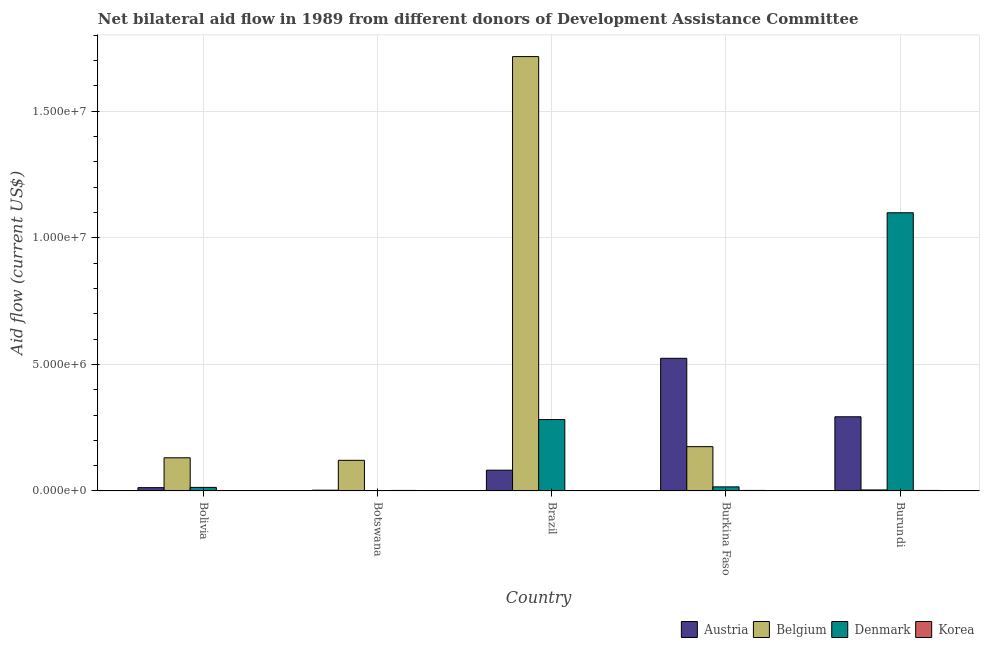How many different coloured bars are there?
Keep it short and to the point. 4. Are the number of bars per tick equal to the number of legend labels?
Your answer should be compact. No. How many bars are there on the 2nd tick from the left?
Your answer should be compact. 3. How many bars are there on the 5th tick from the right?
Make the answer very short. 4. What is the amount of aid given by korea in Burundi?
Offer a very short reply. 2.00e+04. Across all countries, what is the maximum amount of aid given by austria?
Ensure brevity in your answer.  5.24e+06. In which country was the amount of aid given by korea maximum?
Your answer should be compact. Botswana. What is the total amount of aid given by korea in the graph?
Keep it short and to the point. 8.00e+04. What is the difference between the amount of aid given by belgium in Botswana and that in Brazil?
Keep it short and to the point. -1.60e+07. What is the difference between the amount of aid given by austria in Bolivia and the amount of aid given by korea in Botswana?
Make the answer very short. 1.10e+05. What is the average amount of aid given by korea per country?
Your answer should be compact. 1.60e+04. What is the difference between the amount of aid given by denmark and amount of aid given by korea in Burkina Faso?
Offer a terse response. 1.40e+05. What is the ratio of the amount of aid given by korea in Brazil to that in Burkina Faso?
Keep it short and to the point. 0.5. Is the amount of aid given by austria in Brazil less than that in Burkina Faso?
Your answer should be compact. Yes. What is the difference between the highest and the second highest amount of aid given by denmark?
Provide a short and direct response. 8.17e+06. What is the difference between the highest and the lowest amount of aid given by austria?
Give a very brief answer. 5.21e+06. Is it the case that in every country, the sum of the amount of aid given by austria and amount of aid given by korea is greater than the sum of amount of aid given by belgium and amount of aid given by denmark?
Ensure brevity in your answer.  No. Is it the case that in every country, the sum of the amount of aid given by austria and amount of aid given by belgium is greater than the amount of aid given by denmark?
Offer a very short reply. No. How many countries are there in the graph?
Give a very brief answer. 5. Are the values on the major ticks of Y-axis written in scientific E-notation?
Your response must be concise. Yes. Does the graph contain grids?
Provide a short and direct response. Yes. How many legend labels are there?
Offer a terse response. 4. How are the legend labels stacked?
Make the answer very short. Horizontal. What is the title of the graph?
Provide a short and direct response. Net bilateral aid flow in 1989 from different donors of Development Assistance Committee. What is the label or title of the Y-axis?
Your answer should be very brief. Aid flow (current US$). What is the Aid flow (current US$) of Austria in Bolivia?
Your response must be concise. 1.30e+05. What is the Aid flow (current US$) in Belgium in Bolivia?
Your answer should be compact. 1.31e+06. What is the Aid flow (current US$) in Denmark in Bolivia?
Make the answer very short. 1.40e+05. What is the Aid flow (current US$) of Belgium in Botswana?
Provide a short and direct response. 1.21e+06. What is the Aid flow (current US$) in Denmark in Botswana?
Keep it short and to the point. 0. What is the Aid flow (current US$) of Austria in Brazil?
Your answer should be very brief. 8.20e+05. What is the Aid flow (current US$) in Belgium in Brazil?
Keep it short and to the point. 1.72e+07. What is the Aid flow (current US$) in Denmark in Brazil?
Your answer should be very brief. 2.82e+06. What is the Aid flow (current US$) in Austria in Burkina Faso?
Offer a very short reply. 5.24e+06. What is the Aid flow (current US$) of Belgium in Burkina Faso?
Provide a succinct answer. 1.75e+06. What is the Aid flow (current US$) in Korea in Burkina Faso?
Your response must be concise. 2.00e+04. What is the Aid flow (current US$) in Austria in Burundi?
Your answer should be compact. 2.93e+06. What is the Aid flow (current US$) in Denmark in Burundi?
Provide a short and direct response. 1.10e+07. Across all countries, what is the maximum Aid flow (current US$) of Austria?
Your answer should be compact. 5.24e+06. Across all countries, what is the maximum Aid flow (current US$) of Belgium?
Provide a succinct answer. 1.72e+07. Across all countries, what is the maximum Aid flow (current US$) in Denmark?
Provide a succinct answer. 1.10e+07. Across all countries, what is the maximum Aid flow (current US$) of Korea?
Give a very brief answer. 2.00e+04. Across all countries, what is the minimum Aid flow (current US$) of Belgium?
Provide a short and direct response. 4.00e+04. Across all countries, what is the minimum Aid flow (current US$) of Denmark?
Provide a short and direct response. 0. What is the total Aid flow (current US$) in Austria in the graph?
Your response must be concise. 9.15e+06. What is the total Aid flow (current US$) in Belgium in the graph?
Keep it short and to the point. 2.15e+07. What is the total Aid flow (current US$) of Denmark in the graph?
Ensure brevity in your answer.  1.41e+07. What is the total Aid flow (current US$) in Korea in the graph?
Keep it short and to the point. 8.00e+04. What is the difference between the Aid flow (current US$) in Korea in Bolivia and that in Botswana?
Your response must be concise. -10000. What is the difference between the Aid flow (current US$) in Austria in Bolivia and that in Brazil?
Your answer should be compact. -6.90e+05. What is the difference between the Aid flow (current US$) of Belgium in Bolivia and that in Brazil?
Provide a short and direct response. -1.58e+07. What is the difference between the Aid flow (current US$) in Denmark in Bolivia and that in Brazil?
Your answer should be very brief. -2.68e+06. What is the difference between the Aid flow (current US$) of Korea in Bolivia and that in Brazil?
Offer a very short reply. 0. What is the difference between the Aid flow (current US$) of Austria in Bolivia and that in Burkina Faso?
Keep it short and to the point. -5.11e+06. What is the difference between the Aid flow (current US$) in Belgium in Bolivia and that in Burkina Faso?
Make the answer very short. -4.40e+05. What is the difference between the Aid flow (current US$) in Korea in Bolivia and that in Burkina Faso?
Your answer should be compact. -10000. What is the difference between the Aid flow (current US$) of Austria in Bolivia and that in Burundi?
Make the answer very short. -2.80e+06. What is the difference between the Aid flow (current US$) in Belgium in Bolivia and that in Burundi?
Your answer should be compact. 1.27e+06. What is the difference between the Aid flow (current US$) in Denmark in Bolivia and that in Burundi?
Provide a succinct answer. -1.08e+07. What is the difference between the Aid flow (current US$) of Korea in Bolivia and that in Burundi?
Your response must be concise. -10000. What is the difference between the Aid flow (current US$) in Austria in Botswana and that in Brazil?
Ensure brevity in your answer.  -7.90e+05. What is the difference between the Aid flow (current US$) of Belgium in Botswana and that in Brazil?
Your answer should be very brief. -1.60e+07. What is the difference between the Aid flow (current US$) in Austria in Botswana and that in Burkina Faso?
Keep it short and to the point. -5.21e+06. What is the difference between the Aid flow (current US$) of Belgium in Botswana and that in Burkina Faso?
Your response must be concise. -5.40e+05. What is the difference between the Aid flow (current US$) in Austria in Botswana and that in Burundi?
Offer a terse response. -2.90e+06. What is the difference between the Aid flow (current US$) in Belgium in Botswana and that in Burundi?
Provide a succinct answer. 1.17e+06. What is the difference between the Aid flow (current US$) of Austria in Brazil and that in Burkina Faso?
Offer a very short reply. -4.42e+06. What is the difference between the Aid flow (current US$) in Belgium in Brazil and that in Burkina Faso?
Give a very brief answer. 1.54e+07. What is the difference between the Aid flow (current US$) of Denmark in Brazil and that in Burkina Faso?
Offer a terse response. 2.66e+06. What is the difference between the Aid flow (current US$) in Austria in Brazil and that in Burundi?
Provide a succinct answer. -2.11e+06. What is the difference between the Aid flow (current US$) in Belgium in Brazil and that in Burundi?
Ensure brevity in your answer.  1.71e+07. What is the difference between the Aid flow (current US$) of Denmark in Brazil and that in Burundi?
Your answer should be compact. -8.17e+06. What is the difference between the Aid flow (current US$) in Korea in Brazil and that in Burundi?
Your response must be concise. -10000. What is the difference between the Aid flow (current US$) of Austria in Burkina Faso and that in Burundi?
Your answer should be very brief. 2.31e+06. What is the difference between the Aid flow (current US$) in Belgium in Burkina Faso and that in Burundi?
Offer a terse response. 1.71e+06. What is the difference between the Aid flow (current US$) in Denmark in Burkina Faso and that in Burundi?
Offer a very short reply. -1.08e+07. What is the difference between the Aid flow (current US$) in Austria in Bolivia and the Aid flow (current US$) in Belgium in Botswana?
Ensure brevity in your answer.  -1.08e+06. What is the difference between the Aid flow (current US$) in Austria in Bolivia and the Aid flow (current US$) in Korea in Botswana?
Ensure brevity in your answer.  1.10e+05. What is the difference between the Aid flow (current US$) in Belgium in Bolivia and the Aid flow (current US$) in Korea in Botswana?
Ensure brevity in your answer.  1.29e+06. What is the difference between the Aid flow (current US$) of Denmark in Bolivia and the Aid flow (current US$) of Korea in Botswana?
Keep it short and to the point. 1.20e+05. What is the difference between the Aid flow (current US$) of Austria in Bolivia and the Aid flow (current US$) of Belgium in Brazil?
Your answer should be very brief. -1.70e+07. What is the difference between the Aid flow (current US$) of Austria in Bolivia and the Aid flow (current US$) of Denmark in Brazil?
Offer a terse response. -2.69e+06. What is the difference between the Aid flow (current US$) of Austria in Bolivia and the Aid flow (current US$) of Korea in Brazil?
Make the answer very short. 1.20e+05. What is the difference between the Aid flow (current US$) in Belgium in Bolivia and the Aid flow (current US$) in Denmark in Brazil?
Give a very brief answer. -1.51e+06. What is the difference between the Aid flow (current US$) of Belgium in Bolivia and the Aid flow (current US$) of Korea in Brazil?
Your response must be concise. 1.30e+06. What is the difference between the Aid flow (current US$) of Denmark in Bolivia and the Aid flow (current US$) of Korea in Brazil?
Offer a very short reply. 1.30e+05. What is the difference between the Aid flow (current US$) in Austria in Bolivia and the Aid flow (current US$) in Belgium in Burkina Faso?
Your answer should be compact. -1.62e+06. What is the difference between the Aid flow (current US$) in Austria in Bolivia and the Aid flow (current US$) in Denmark in Burkina Faso?
Provide a succinct answer. -3.00e+04. What is the difference between the Aid flow (current US$) of Belgium in Bolivia and the Aid flow (current US$) of Denmark in Burkina Faso?
Offer a very short reply. 1.15e+06. What is the difference between the Aid flow (current US$) in Belgium in Bolivia and the Aid flow (current US$) in Korea in Burkina Faso?
Your answer should be very brief. 1.29e+06. What is the difference between the Aid flow (current US$) in Austria in Bolivia and the Aid flow (current US$) in Denmark in Burundi?
Offer a terse response. -1.09e+07. What is the difference between the Aid flow (current US$) in Belgium in Bolivia and the Aid flow (current US$) in Denmark in Burundi?
Provide a short and direct response. -9.68e+06. What is the difference between the Aid flow (current US$) of Belgium in Bolivia and the Aid flow (current US$) of Korea in Burundi?
Give a very brief answer. 1.29e+06. What is the difference between the Aid flow (current US$) of Denmark in Bolivia and the Aid flow (current US$) of Korea in Burundi?
Make the answer very short. 1.20e+05. What is the difference between the Aid flow (current US$) of Austria in Botswana and the Aid flow (current US$) of Belgium in Brazil?
Your answer should be compact. -1.71e+07. What is the difference between the Aid flow (current US$) of Austria in Botswana and the Aid flow (current US$) of Denmark in Brazil?
Offer a terse response. -2.79e+06. What is the difference between the Aid flow (current US$) of Belgium in Botswana and the Aid flow (current US$) of Denmark in Brazil?
Your answer should be very brief. -1.61e+06. What is the difference between the Aid flow (current US$) of Belgium in Botswana and the Aid flow (current US$) of Korea in Brazil?
Offer a very short reply. 1.20e+06. What is the difference between the Aid flow (current US$) in Austria in Botswana and the Aid flow (current US$) in Belgium in Burkina Faso?
Make the answer very short. -1.72e+06. What is the difference between the Aid flow (current US$) in Austria in Botswana and the Aid flow (current US$) in Denmark in Burkina Faso?
Your response must be concise. -1.30e+05. What is the difference between the Aid flow (current US$) in Belgium in Botswana and the Aid flow (current US$) in Denmark in Burkina Faso?
Offer a very short reply. 1.05e+06. What is the difference between the Aid flow (current US$) in Belgium in Botswana and the Aid flow (current US$) in Korea in Burkina Faso?
Offer a terse response. 1.19e+06. What is the difference between the Aid flow (current US$) of Austria in Botswana and the Aid flow (current US$) of Denmark in Burundi?
Give a very brief answer. -1.10e+07. What is the difference between the Aid flow (current US$) of Austria in Botswana and the Aid flow (current US$) of Korea in Burundi?
Give a very brief answer. 10000. What is the difference between the Aid flow (current US$) of Belgium in Botswana and the Aid flow (current US$) of Denmark in Burundi?
Offer a terse response. -9.78e+06. What is the difference between the Aid flow (current US$) in Belgium in Botswana and the Aid flow (current US$) in Korea in Burundi?
Provide a succinct answer. 1.19e+06. What is the difference between the Aid flow (current US$) of Austria in Brazil and the Aid flow (current US$) of Belgium in Burkina Faso?
Offer a terse response. -9.30e+05. What is the difference between the Aid flow (current US$) in Belgium in Brazil and the Aid flow (current US$) in Denmark in Burkina Faso?
Your answer should be compact. 1.70e+07. What is the difference between the Aid flow (current US$) of Belgium in Brazil and the Aid flow (current US$) of Korea in Burkina Faso?
Provide a succinct answer. 1.71e+07. What is the difference between the Aid flow (current US$) of Denmark in Brazil and the Aid flow (current US$) of Korea in Burkina Faso?
Your response must be concise. 2.80e+06. What is the difference between the Aid flow (current US$) of Austria in Brazil and the Aid flow (current US$) of Belgium in Burundi?
Offer a very short reply. 7.80e+05. What is the difference between the Aid flow (current US$) of Austria in Brazil and the Aid flow (current US$) of Denmark in Burundi?
Keep it short and to the point. -1.02e+07. What is the difference between the Aid flow (current US$) in Austria in Brazil and the Aid flow (current US$) in Korea in Burundi?
Offer a very short reply. 8.00e+05. What is the difference between the Aid flow (current US$) in Belgium in Brazil and the Aid flow (current US$) in Denmark in Burundi?
Your answer should be compact. 6.17e+06. What is the difference between the Aid flow (current US$) of Belgium in Brazil and the Aid flow (current US$) of Korea in Burundi?
Your response must be concise. 1.71e+07. What is the difference between the Aid flow (current US$) in Denmark in Brazil and the Aid flow (current US$) in Korea in Burundi?
Give a very brief answer. 2.80e+06. What is the difference between the Aid flow (current US$) of Austria in Burkina Faso and the Aid flow (current US$) of Belgium in Burundi?
Offer a terse response. 5.20e+06. What is the difference between the Aid flow (current US$) of Austria in Burkina Faso and the Aid flow (current US$) of Denmark in Burundi?
Offer a terse response. -5.75e+06. What is the difference between the Aid flow (current US$) of Austria in Burkina Faso and the Aid flow (current US$) of Korea in Burundi?
Your answer should be compact. 5.22e+06. What is the difference between the Aid flow (current US$) of Belgium in Burkina Faso and the Aid flow (current US$) of Denmark in Burundi?
Your answer should be very brief. -9.24e+06. What is the difference between the Aid flow (current US$) of Belgium in Burkina Faso and the Aid flow (current US$) of Korea in Burundi?
Give a very brief answer. 1.73e+06. What is the difference between the Aid flow (current US$) in Denmark in Burkina Faso and the Aid flow (current US$) in Korea in Burundi?
Your answer should be compact. 1.40e+05. What is the average Aid flow (current US$) in Austria per country?
Offer a very short reply. 1.83e+06. What is the average Aid flow (current US$) of Belgium per country?
Provide a succinct answer. 4.29e+06. What is the average Aid flow (current US$) in Denmark per country?
Give a very brief answer. 2.82e+06. What is the average Aid flow (current US$) of Korea per country?
Keep it short and to the point. 1.60e+04. What is the difference between the Aid flow (current US$) of Austria and Aid flow (current US$) of Belgium in Bolivia?
Offer a very short reply. -1.18e+06. What is the difference between the Aid flow (current US$) in Austria and Aid flow (current US$) in Denmark in Bolivia?
Provide a succinct answer. -10000. What is the difference between the Aid flow (current US$) in Austria and Aid flow (current US$) in Korea in Bolivia?
Ensure brevity in your answer.  1.20e+05. What is the difference between the Aid flow (current US$) of Belgium and Aid flow (current US$) of Denmark in Bolivia?
Ensure brevity in your answer.  1.17e+06. What is the difference between the Aid flow (current US$) in Belgium and Aid flow (current US$) in Korea in Bolivia?
Your answer should be compact. 1.30e+06. What is the difference between the Aid flow (current US$) in Denmark and Aid flow (current US$) in Korea in Bolivia?
Your answer should be compact. 1.30e+05. What is the difference between the Aid flow (current US$) of Austria and Aid flow (current US$) of Belgium in Botswana?
Offer a very short reply. -1.18e+06. What is the difference between the Aid flow (current US$) in Austria and Aid flow (current US$) in Korea in Botswana?
Keep it short and to the point. 10000. What is the difference between the Aid flow (current US$) of Belgium and Aid flow (current US$) of Korea in Botswana?
Your answer should be very brief. 1.19e+06. What is the difference between the Aid flow (current US$) of Austria and Aid flow (current US$) of Belgium in Brazil?
Keep it short and to the point. -1.63e+07. What is the difference between the Aid flow (current US$) in Austria and Aid flow (current US$) in Korea in Brazil?
Give a very brief answer. 8.10e+05. What is the difference between the Aid flow (current US$) of Belgium and Aid flow (current US$) of Denmark in Brazil?
Keep it short and to the point. 1.43e+07. What is the difference between the Aid flow (current US$) of Belgium and Aid flow (current US$) of Korea in Brazil?
Provide a short and direct response. 1.72e+07. What is the difference between the Aid flow (current US$) in Denmark and Aid flow (current US$) in Korea in Brazil?
Your answer should be very brief. 2.81e+06. What is the difference between the Aid flow (current US$) of Austria and Aid flow (current US$) of Belgium in Burkina Faso?
Provide a succinct answer. 3.49e+06. What is the difference between the Aid flow (current US$) of Austria and Aid flow (current US$) of Denmark in Burkina Faso?
Give a very brief answer. 5.08e+06. What is the difference between the Aid flow (current US$) in Austria and Aid flow (current US$) in Korea in Burkina Faso?
Give a very brief answer. 5.22e+06. What is the difference between the Aid flow (current US$) of Belgium and Aid flow (current US$) of Denmark in Burkina Faso?
Your answer should be very brief. 1.59e+06. What is the difference between the Aid flow (current US$) in Belgium and Aid flow (current US$) in Korea in Burkina Faso?
Your answer should be very brief. 1.73e+06. What is the difference between the Aid flow (current US$) in Denmark and Aid flow (current US$) in Korea in Burkina Faso?
Give a very brief answer. 1.40e+05. What is the difference between the Aid flow (current US$) in Austria and Aid flow (current US$) in Belgium in Burundi?
Offer a very short reply. 2.89e+06. What is the difference between the Aid flow (current US$) of Austria and Aid flow (current US$) of Denmark in Burundi?
Your response must be concise. -8.06e+06. What is the difference between the Aid flow (current US$) in Austria and Aid flow (current US$) in Korea in Burundi?
Your answer should be compact. 2.91e+06. What is the difference between the Aid flow (current US$) of Belgium and Aid flow (current US$) of Denmark in Burundi?
Make the answer very short. -1.10e+07. What is the difference between the Aid flow (current US$) in Belgium and Aid flow (current US$) in Korea in Burundi?
Ensure brevity in your answer.  2.00e+04. What is the difference between the Aid flow (current US$) in Denmark and Aid flow (current US$) in Korea in Burundi?
Offer a terse response. 1.10e+07. What is the ratio of the Aid flow (current US$) of Austria in Bolivia to that in Botswana?
Offer a very short reply. 4.33. What is the ratio of the Aid flow (current US$) of Belgium in Bolivia to that in Botswana?
Offer a terse response. 1.08. What is the ratio of the Aid flow (current US$) in Korea in Bolivia to that in Botswana?
Your response must be concise. 0.5. What is the ratio of the Aid flow (current US$) of Austria in Bolivia to that in Brazil?
Provide a succinct answer. 0.16. What is the ratio of the Aid flow (current US$) of Belgium in Bolivia to that in Brazil?
Your response must be concise. 0.08. What is the ratio of the Aid flow (current US$) in Denmark in Bolivia to that in Brazil?
Your answer should be compact. 0.05. What is the ratio of the Aid flow (current US$) in Austria in Bolivia to that in Burkina Faso?
Your response must be concise. 0.02. What is the ratio of the Aid flow (current US$) of Belgium in Bolivia to that in Burkina Faso?
Your answer should be compact. 0.75. What is the ratio of the Aid flow (current US$) of Denmark in Bolivia to that in Burkina Faso?
Your answer should be compact. 0.88. What is the ratio of the Aid flow (current US$) of Austria in Bolivia to that in Burundi?
Ensure brevity in your answer.  0.04. What is the ratio of the Aid flow (current US$) in Belgium in Bolivia to that in Burundi?
Provide a short and direct response. 32.75. What is the ratio of the Aid flow (current US$) of Denmark in Bolivia to that in Burundi?
Ensure brevity in your answer.  0.01. What is the ratio of the Aid flow (current US$) of Korea in Bolivia to that in Burundi?
Provide a succinct answer. 0.5. What is the ratio of the Aid flow (current US$) in Austria in Botswana to that in Brazil?
Provide a short and direct response. 0.04. What is the ratio of the Aid flow (current US$) in Belgium in Botswana to that in Brazil?
Your answer should be compact. 0.07. What is the ratio of the Aid flow (current US$) in Korea in Botswana to that in Brazil?
Your response must be concise. 2. What is the ratio of the Aid flow (current US$) in Austria in Botswana to that in Burkina Faso?
Provide a short and direct response. 0.01. What is the ratio of the Aid flow (current US$) in Belgium in Botswana to that in Burkina Faso?
Your answer should be compact. 0.69. What is the ratio of the Aid flow (current US$) of Austria in Botswana to that in Burundi?
Keep it short and to the point. 0.01. What is the ratio of the Aid flow (current US$) of Belgium in Botswana to that in Burundi?
Keep it short and to the point. 30.25. What is the ratio of the Aid flow (current US$) in Austria in Brazil to that in Burkina Faso?
Make the answer very short. 0.16. What is the ratio of the Aid flow (current US$) of Belgium in Brazil to that in Burkina Faso?
Your answer should be very brief. 9.81. What is the ratio of the Aid flow (current US$) of Denmark in Brazil to that in Burkina Faso?
Make the answer very short. 17.62. What is the ratio of the Aid flow (current US$) of Korea in Brazil to that in Burkina Faso?
Your answer should be very brief. 0.5. What is the ratio of the Aid flow (current US$) of Austria in Brazil to that in Burundi?
Your answer should be compact. 0.28. What is the ratio of the Aid flow (current US$) in Belgium in Brazil to that in Burundi?
Offer a terse response. 429. What is the ratio of the Aid flow (current US$) of Denmark in Brazil to that in Burundi?
Your response must be concise. 0.26. What is the ratio of the Aid flow (current US$) in Korea in Brazil to that in Burundi?
Provide a short and direct response. 0.5. What is the ratio of the Aid flow (current US$) in Austria in Burkina Faso to that in Burundi?
Your answer should be very brief. 1.79. What is the ratio of the Aid flow (current US$) of Belgium in Burkina Faso to that in Burundi?
Offer a terse response. 43.75. What is the ratio of the Aid flow (current US$) in Denmark in Burkina Faso to that in Burundi?
Keep it short and to the point. 0.01. What is the difference between the highest and the second highest Aid flow (current US$) in Austria?
Offer a terse response. 2.31e+06. What is the difference between the highest and the second highest Aid flow (current US$) of Belgium?
Your answer should be very brief. 1.54e+07. What is the difference between the highest and the second highest Aid flow (current US$) of Denmark?
Offer a very short reply. 8.17e+06. What is the difference between the highest and the second highest Aid flow (current US$) in Korea?
Give a very brief answer. 0. What is the difference between the highest and the lowest Aid flow (current US$) of Austria?
Offer a very short reply. 5.21e+06. What is the difference between the highest and the lowest Aid flow (current US$) in Belgium?
Make the answer very short. 1.71e+07. What is the difference between the highest and the lowest Aid flow (current US$) in Denmark?
Offer a terse response. 1.10e+07. What is the difference between the highest and the lowest Aid flow (current US$) in Korea?
Your answer should be very brief. 10000. 